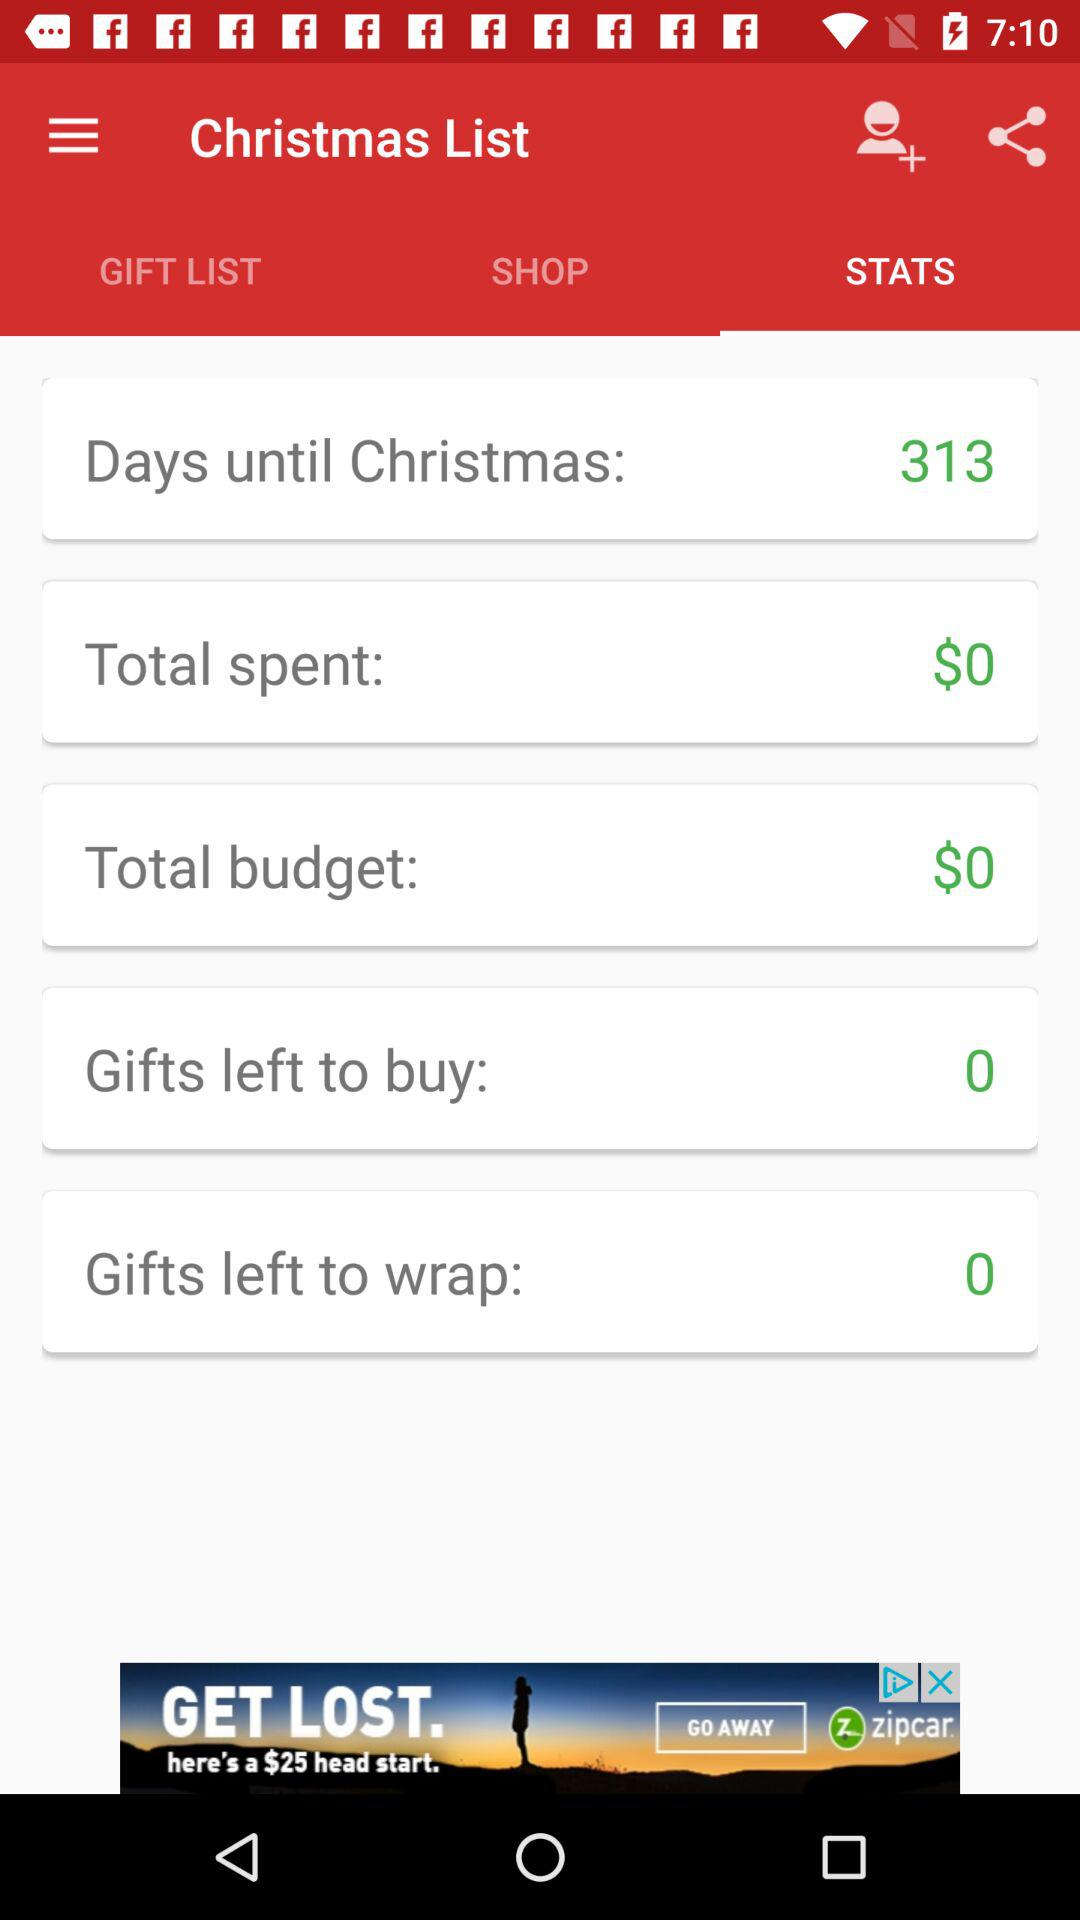How many more gifts need to be purchased than wrapped?
Answer the question using a single word or phrase. 0 